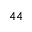Convert formula to latex. <formula><loc_0><loc_0><loc_500><loc_500>^ { 4 4 }</formula> 